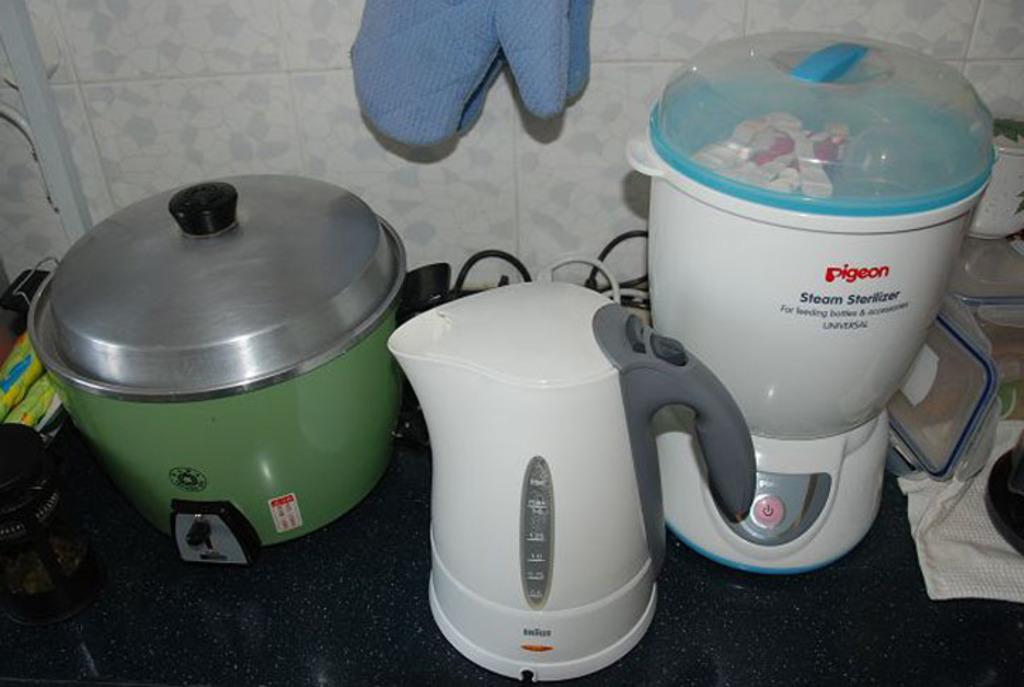What brand of steam sterilizer is shown here?
Your answer should be very brief. Pigeon. What bird is the brand named after?
Make the answer very short. Pigeon. 